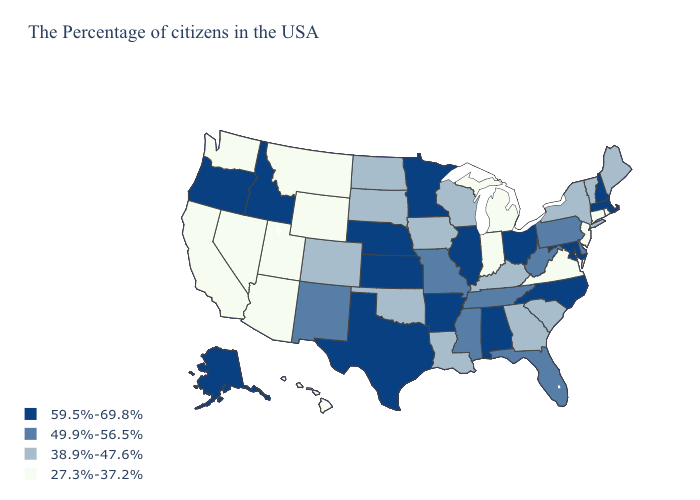Name the states that have a value in the range 49.9%-56.5%?
Keep it brief. Delaware, Pennsylvania, West Virginia, Florida, Tennessee, Mississippi, Missouri, New Mexico. Does Wisconsin have the lowest value in the MidWest?
Concise answer only. No. Name the states that have a value in the range 49.9%-56.5%?
Answer briefly. Delaware, Pennsylvania, West Virginia, Florida, Tennessee, Mississippi, Missouri, New Mexico. Is the legend a continuous bar?
Write a very short answer. No. What is the value of West Virginia?
Short answer required. 49.9%-56.5%. What is the lowest value in states that border New Jersey?
Short answer required. 38.9%-47.6%. What is the value of Florida?
Write a very short answer. 49.9%-56.5%. Does Georgia have the highest value in the USA?
Short answer required. No. Which states have the highest value in the USA?
Answer briefly. Massachusetts, New Hampshire, Maryland, North Carolina, Ohio, Alabama, Illinois, Arkansas, Minnesota, Kansas, Nebraska, Texas, Idaho, Oregon, Alaska. Name the states that have a value in the range 59.5%-69.8%?
Concise answer only. Massachusetts, New Hampshire, Maryland, North Carolina, Ohio, Alabama, Illinois, Arkansas, Minnesota, Kansas, Nebraska, Texas, Idaho, Oregon, Alaska. What is the highest value in states that border Connecticut?
Short answer required. 59.5%-69.8%. Name the states that have a value in the range 49.9%-56.5%?
Write a very short answer. Delaware, Pennsylvania, West Virginia, Florida, Tennessee, Mississippi, Missouri, New Mexico. Name the states that have a value in the range 27.3%-37.2%?
Concise answer only. Rhode Island, Connecticut, New Jersey, Virginia, Michigan, Indiana, Wyoming, Utah, Montana, Arizona, Nevada, California, Washington, Hawaii. Name the states that have a value in the range 59.5%-69.8%?
Keep it brief. Massachusetts, New Hampshire, Maryland, North Carolina, Ohio, Alabama, Illinois, Arkansas, Minnesota, Kansas, Nebraska, Texas, Idaho, Oregon, Alaska. What is the highest value in states that border Ohio?
Concise answer only. 49.9%-56.5%. 